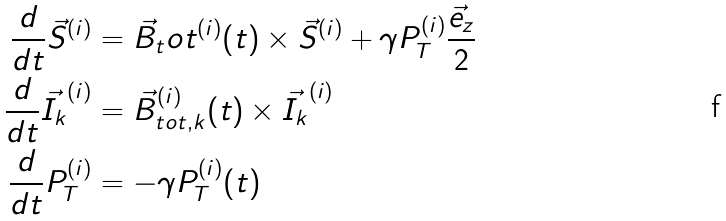Convert formula to latex. <formula><loc_0><loc_0><loc_500><loc_500>\frac { d } { d t } \vec { S } ^ { ( i ) } & = \vec { B } _ { t } o t ^ { ( i ) } ( t ) \times \vec { S } ^ { ( i ) } + \gamma P _ { T } ^ { ( i ) } \frac { \vec { e } _ { z } } { 2 } \\ \frac { d } { d t } \vec { I _ { k } } ^ { ( i ) } & = \vec { B } _ { t o t , k } ^ { ( i ) } ( t ) \times \vec { I _ { k } } ^ { ( i ) } \\ \frac { d } { d t } P _ { T } ^ { ( i ) } & = - \gamma P _ { T } ^ { ( i ) } ( t )</formula> 